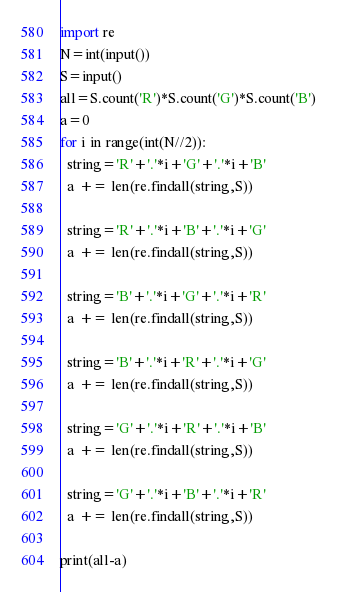Convert code to text. <code><loc_0><loc_0><loc_500><loc_500><_Python_>import re
N=int(input())
S=input()
all=S.count('R')*S.count('G')*S.count('B')
a=0
for i in range(int(N//2)):
  string='R'+'.'*i+'G'+'.'*i+'B'
  a += len(re.findall(string,S))
  
  string='R'+'.'*i+'B'+'.'*i+'G'
  a += len(re.findall(string,S))
  
  string='B'+'.'*i+'G'+'.'*i+'R'
  a += len(re.findall(string,S))
  
  string='B'+'.'*i+'R'+'.'*i+'G'
  a += len(re.findall(string,S))
  
  string='G'+'.'*i+'R'+'.'*i+'B'
  a += len(re.findall(string,S))
  
  string='G'+'.'*i+'B'+'.'*i+'R'
  a += len(re.findall(string,S))
  
print(all-a)</code> 